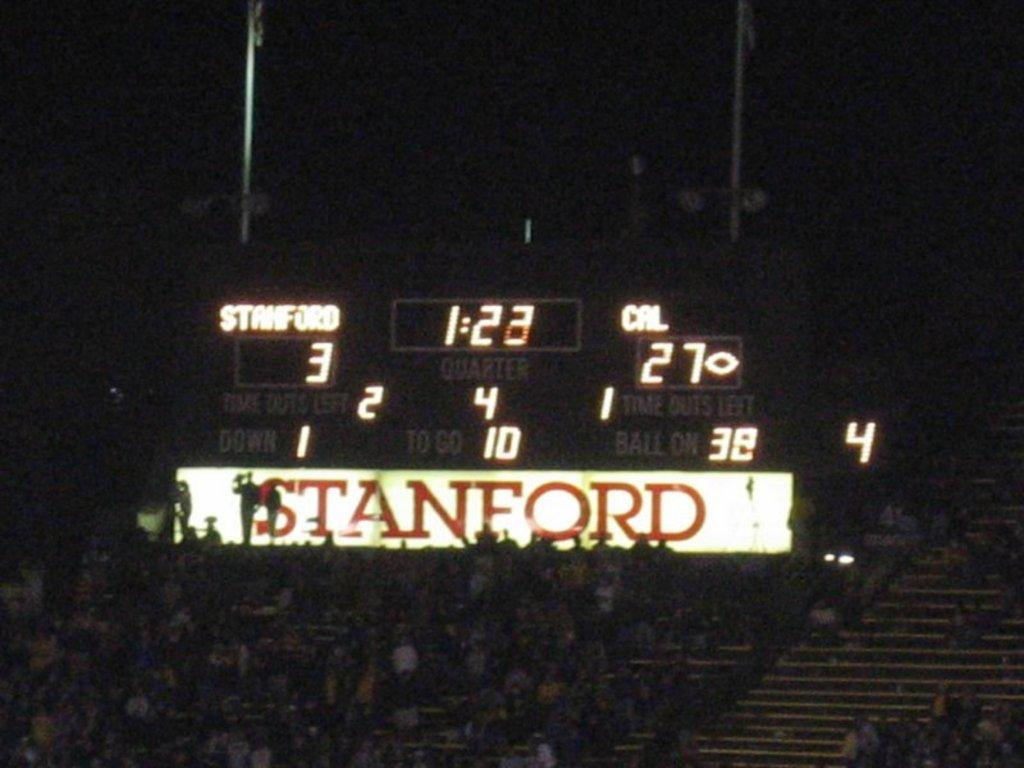<image>
Provide a brief description of the given image. Scoreboard keeping track of the game between Stanford and CAL. 